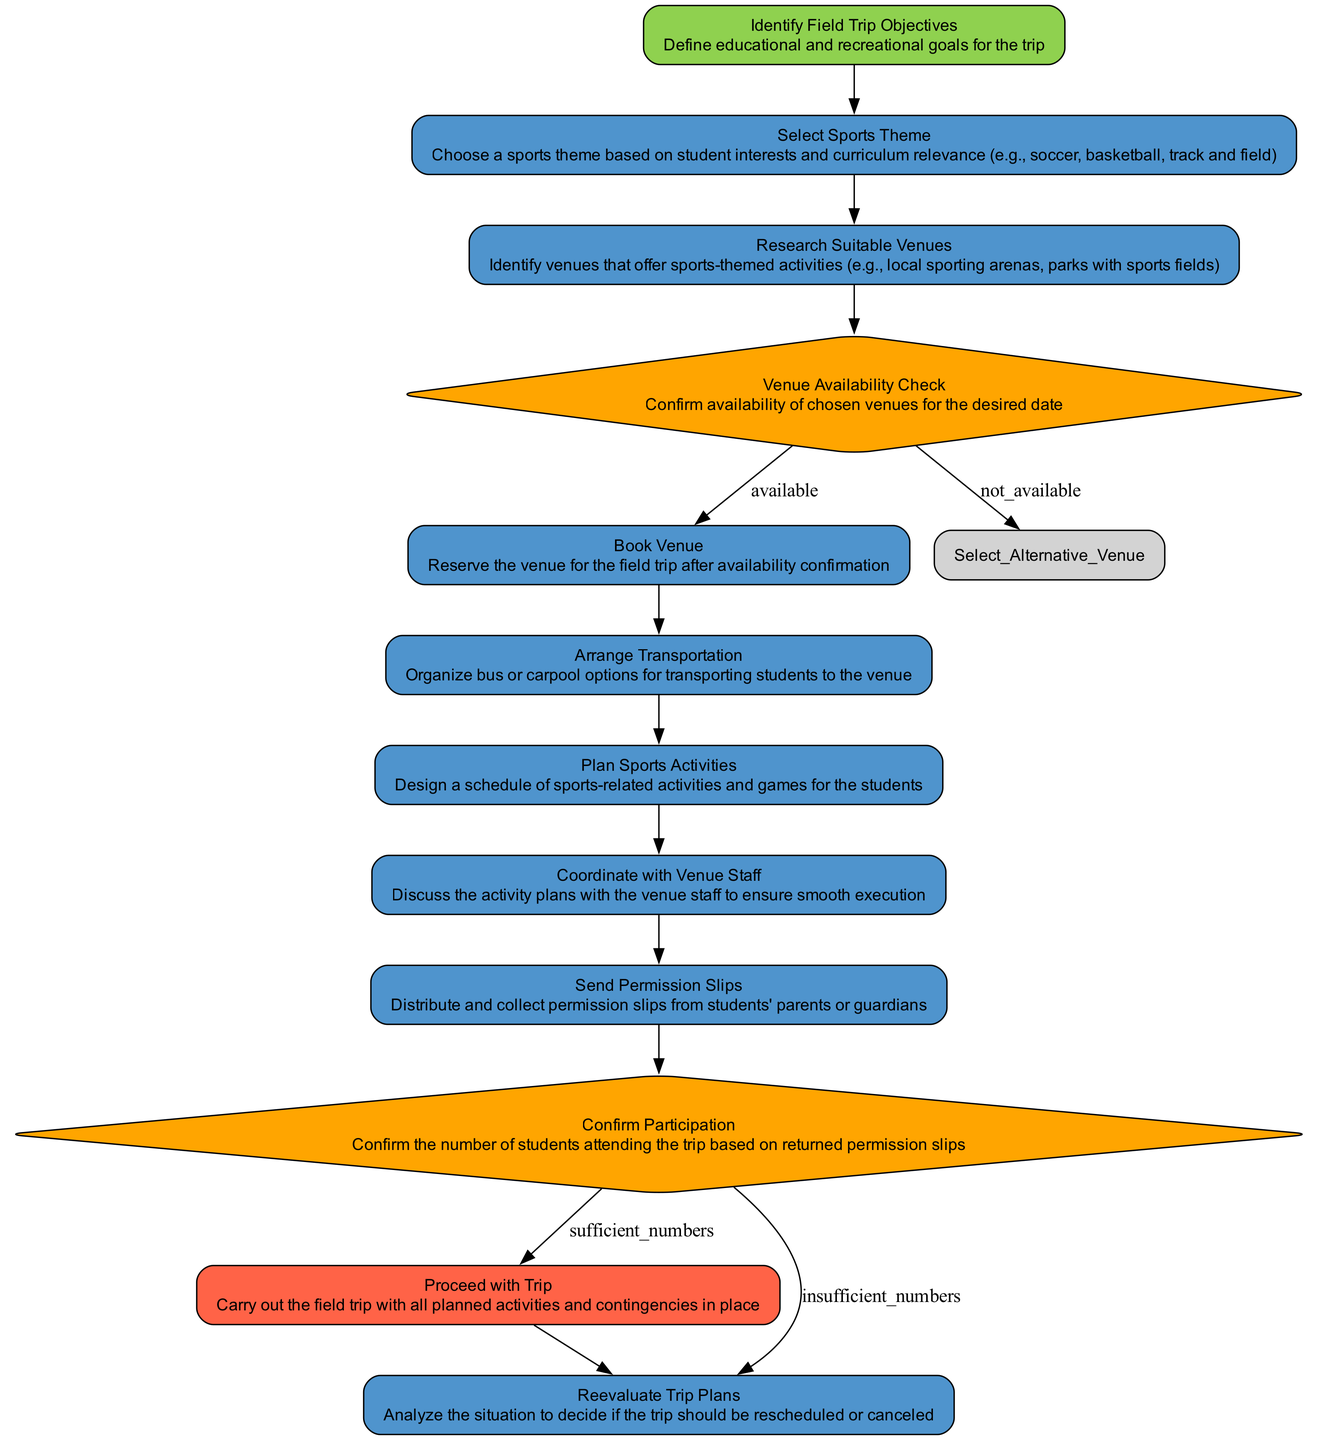What is the first step in the process? The first step is 'Identify Field Trip Objectives', which sets the foundation for the field trip by defining its goals.
Answer: Identify Field Trip Objectives How many decision nodes are present in the diagram? There are two decision nodes: 'Venue Availability Check' and 'Confirm Participation'.
Answer: 2 What happens if the venue is not available? If the venue is not available, the next step is to 'Select Alternative Venue', allowing for the possibility of another location.
Answer: Select Alternative Venue What is the last step in the process? The last step is 'Proceed with Trip', which signifies the completion of planning and moving forward with the trip.
Answer: Proceed with Trip What is the relationship between 'Arrange Transportation' and 'Book Venue'? 'Arrange Transportation' follows after 'Book Venue', indicating that transportation is organized after venue reservation is confirmed.
Answer: 'Arrange Transportation' follows 'Book Venue' What must happen after sending permission slips? After sending permission slips, the next step is 'Confirm Participation', where the number of attendees is assessed based on responses.
Answer: Confirm Participation What decision is made based on the number of students attending? The decision made is either to 'Proceed with Trip' if there are sufficient numbers or 'Reevaluate Trip Plans' if there are insufficient numbers.
Answer: Proceed with Trip or Reevaluate Trip Plans How do you confirm the venue for the trip? To confirm the venue, the node 'Venue Availability Check' must be completed first, leading to either booking the venue or selecting an alternative.
Answer: Check venue availability What is required before proceeding with the field trip? Before proceeding with the field trip, 'Confirm Participation' must be completed to ensure there are enough students attending.
Answer: Confirm Participation 